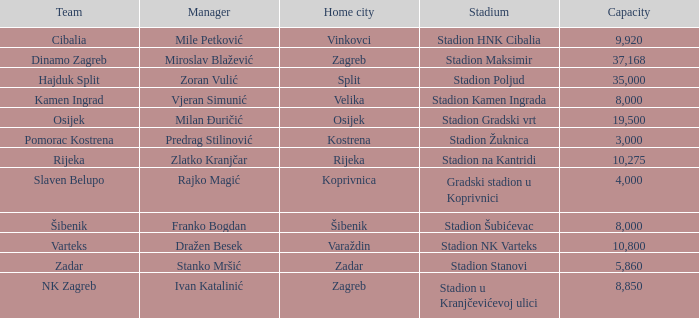What is the sports ground of the nk zagreb? Stadion u Kranjčevićevoj ulici. 